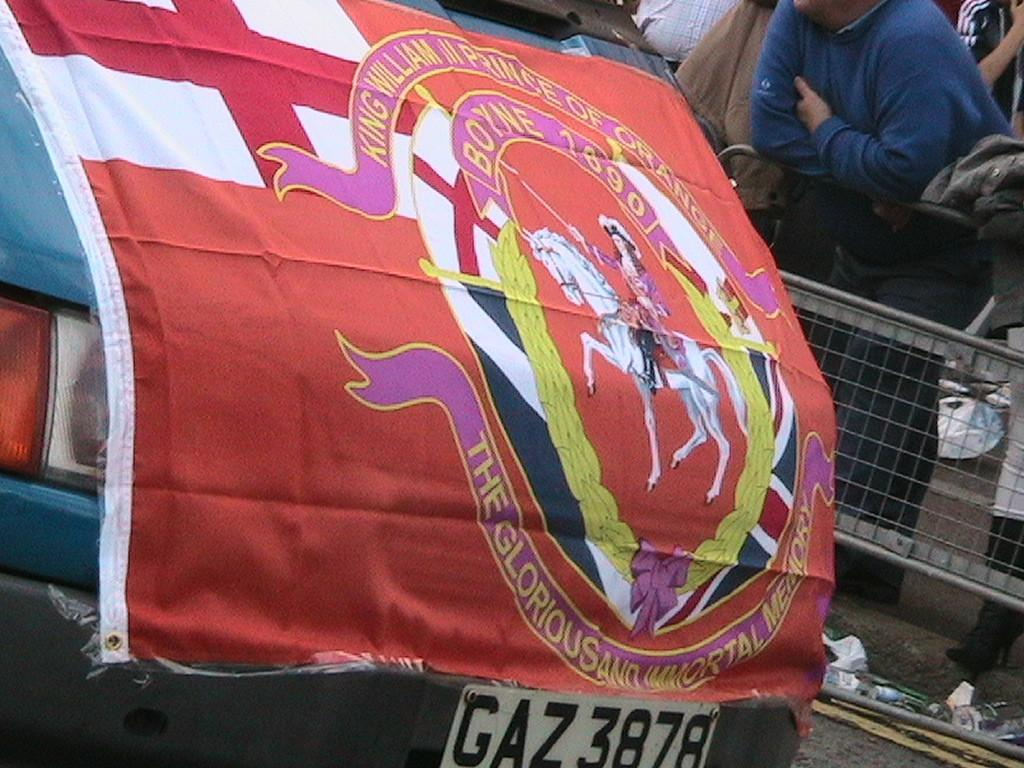What is on the cloth that is visible in the image? There is a logo and text on the cloth in the image. Where is the cloth located in the image? The cloth is placed on a car. What are the people in the image doing? The people are standing beside a fence. What type of lettuce can be seen growing near the fence in the image? There is no lettuce visible in the image; the people are standing beside a fence, but no plants or crops are mentioned. 